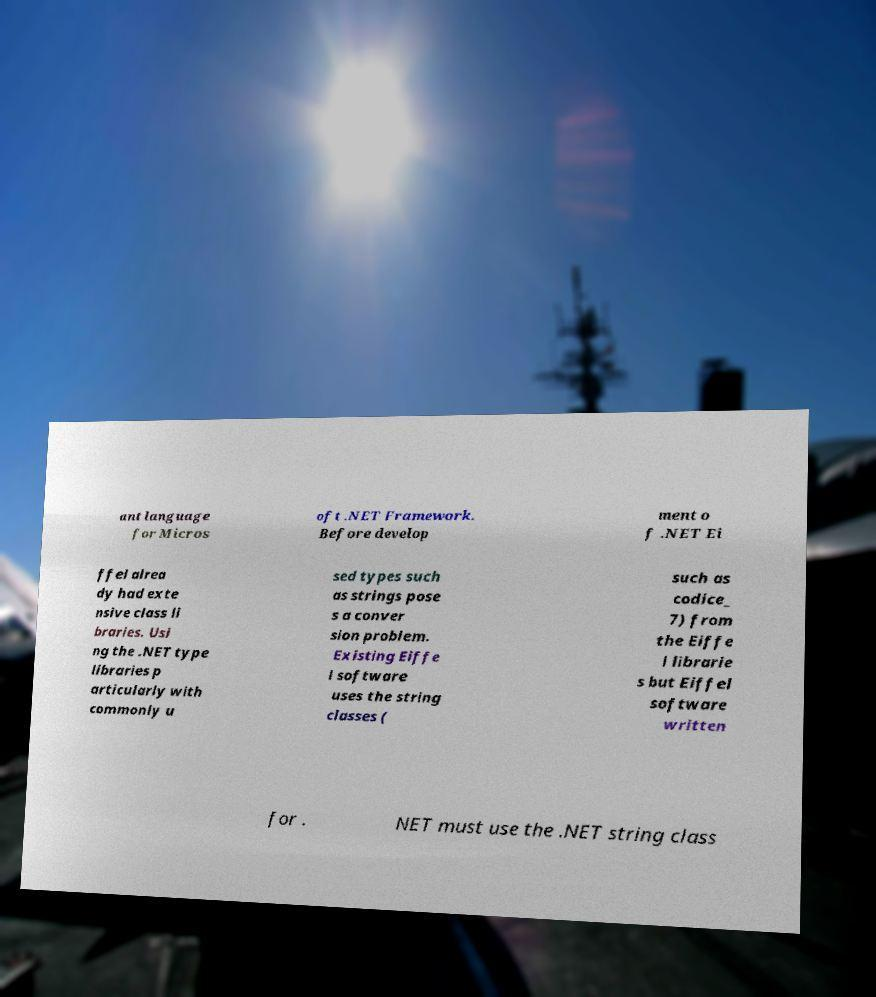There's text embedded in this image that I need extracted. Can you transcribe it verbatim? ant language for Micros oft .NET Framework. Before develop ment o f .NET Ei ffel alrea dy had exte nsive class li braries. Usi ng the .NET type libraries p articularly with commonly u sed types such as strings pose s a conver sion problem. Existing Eiffe l software uses the string classes ( such as codice_ 7) from the Eiffe l librarie s but Eiffel software written for . NET must use the .NET string class 